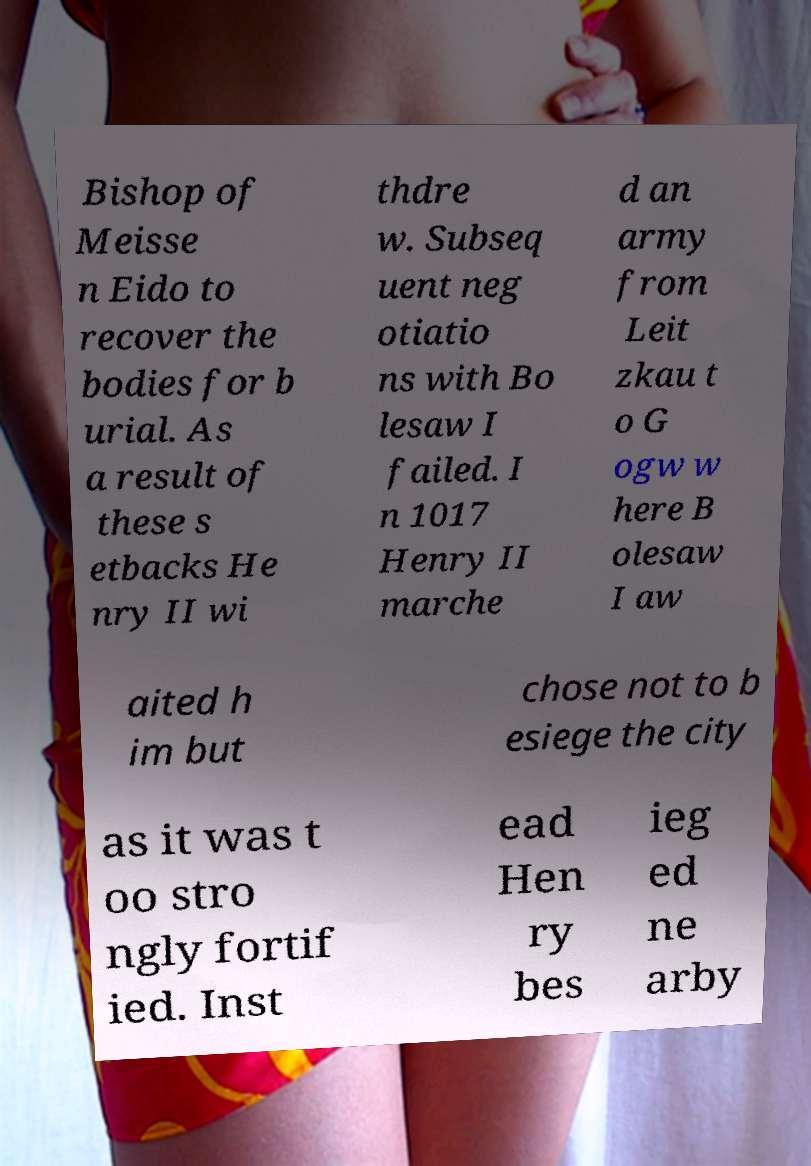Can you accurately transcribe the text from the provided image for me? Bishop of Meisse n Eido to recover the bodies for b urial. As a result of these s etbacks He nry II wi thdre w. Subseq uent neg otiatio ns with Bo lesaw I failed. I n 1017 Henry II marche d an army from Leit zkau t o G ogw w here B olesaw I aw aited h im but chose not to b esiege the city as it was t oo stro ngly fortif ied. Inst ead Hen ry bes ieg ed ne arby 